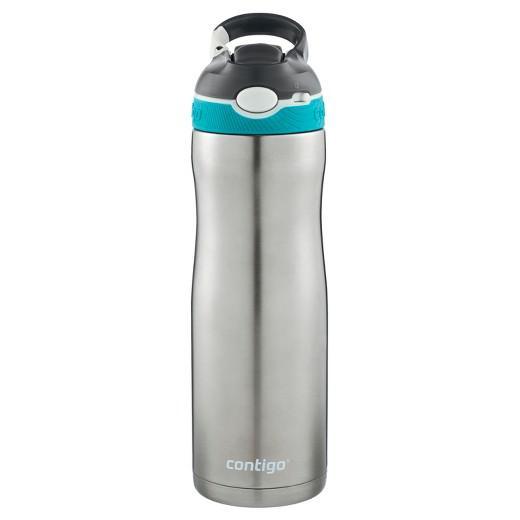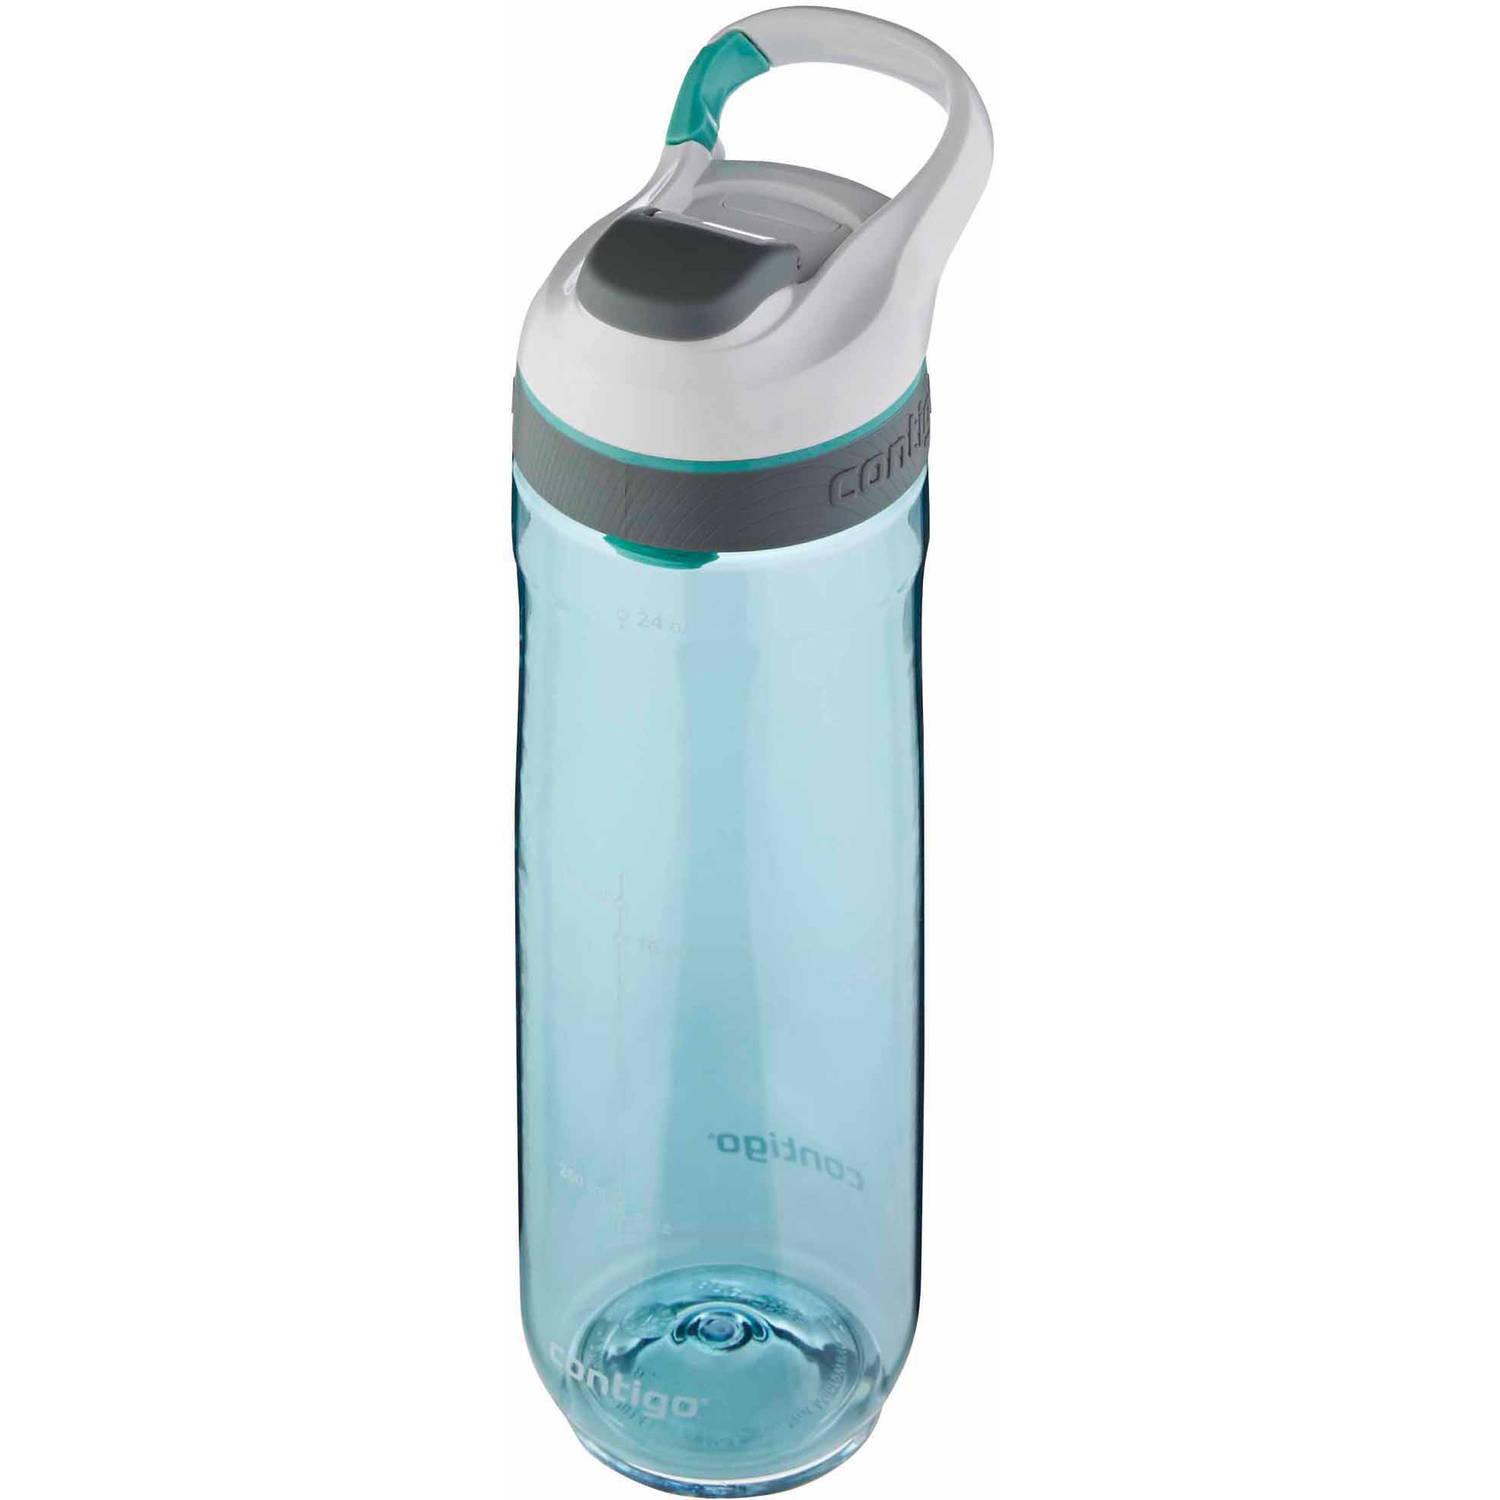The first image is the image on the left, the second image is the image on the right. Considering the images on both sides, is "At least one of the bottles in the image is pink." valid? Answer yes or no. No. 